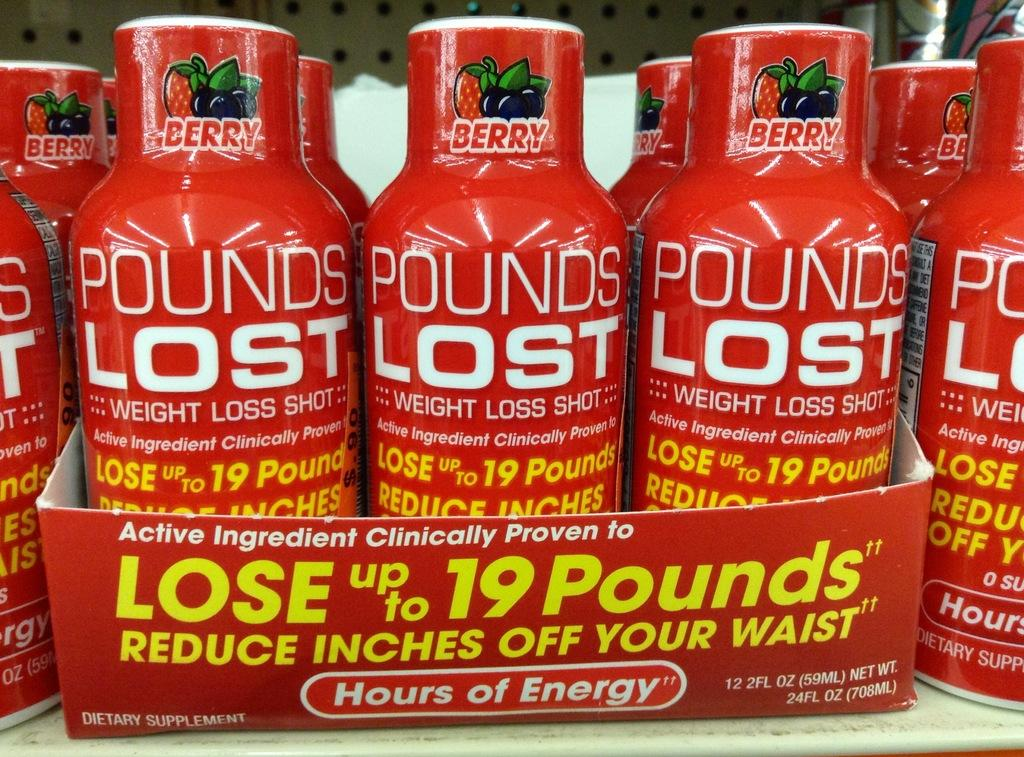<image>
Describe the image concisely. Red bottles which tells people they can lose 19 pounds. 